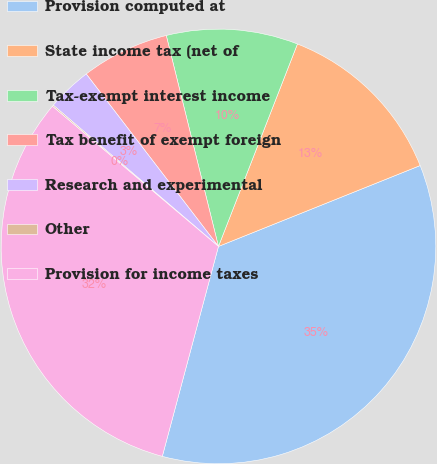Convert chart to OTSL. <chart><loc_0><loc_0><loc_500><loc_500><pie_chart><fcel>Provision computed at<fcel>State income tax (net of<fcel>Tax-exempt interest income<fcel>Tax benefit of exempt foreign<fcel>Research and experimental<fcel>Other<fcel>Provision for income taxes<nl><fcel>35.23%<fcel>13.01%<fcel>9.78%<fcel>6.55%<fcel>3.33%<fcel>0.1%<fcel>32.0%<nl></chart> 